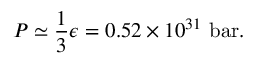<formula> <loc_0><loc_0><loc_500><loc_500>P \simeq { \frac { 1 } { 3 } } \epsilon = 0 . 5 2 \times 1 0 ^ { 3 1 } { b a r } .</formula> 